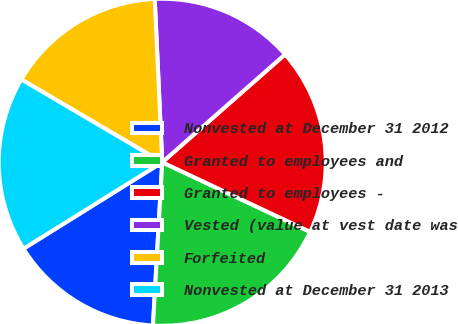Convert chart. <chart><loc_0><loc_0><loc_500><loc_500><pie_chart><fcel>Nonvested at December 31 2012<fcel>Granted to employees and<fcel>Granted to employees -<fcel>Vested (value at vest date was<fcel>Forfeited<fcel>Nonvested at December 31 2013<nl><fcel>15.23%<fcel>18.9%<fcel>18.47%<fcel>14.26%<fcel>15.81%<fcel>17.32%<nl></chart> 